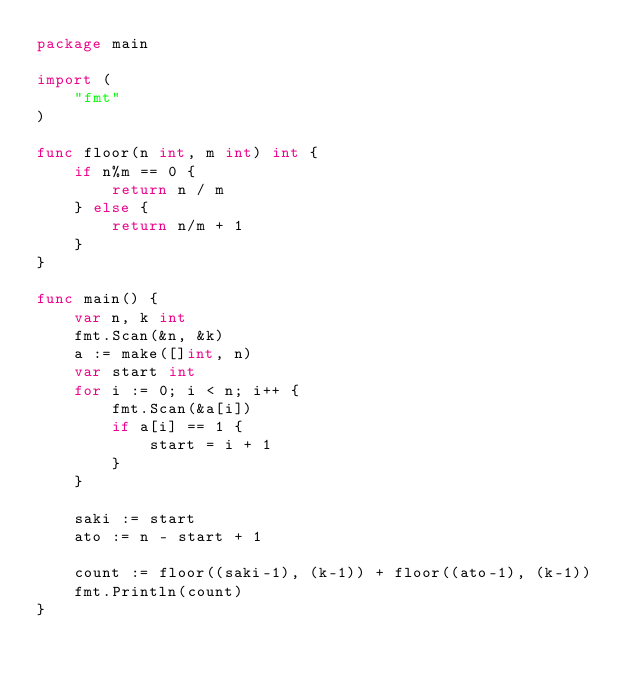Convert code to text. <code><loc_0><loc_0><loc_500><loc_500><_Go_>package main

import (
	"fmt"
)

func floor(n int, m int) int {
	if n%m == 0 {
		return n / m
	} else {
		return n/m + 1
	}
}

func main() {
	var n, k int
	fmt.Scan(&n, &k)
	a := make([]int, n)
	var start int
	for i := 0; i < n; i++ {
		fmt.Scan(&a[i])
		if a[i] == 1 {
			start = i + 1
		}
	}

	saki := start
	ato := n - start + 1

	count := floor((saki-1), (k-1)) + floor((ato-1), (k-1))
	fmt.Println(count)
}
</code> 